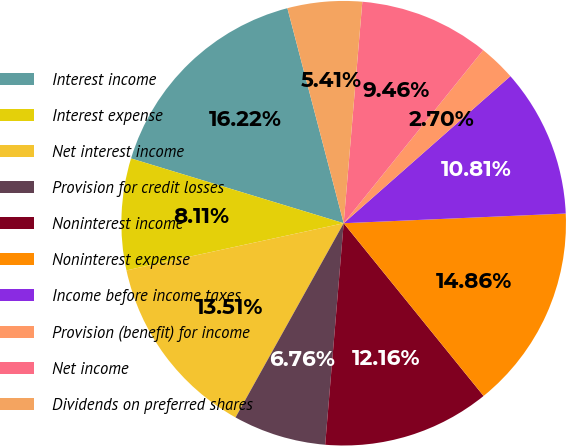Convert chart to OTSL. <chart><loc_0><loc_0><loc_500><loc_500><pie_chart><fcel>Interest income<fcel>Interest expense<fcel>Net interest income<fcel>Provision for credit losses<fcel>Noninterest income<fcel>Noninterest expense<fcel>Income before income taxes<fcel>Provision (benefit) for income<fcel>Net income<fcel>Dividends on preferred shares<nl><fcel>16.22%<fcel>8.11%<fcel>13.51%<fcel>6.76%<fcel>12.16%<fcel>14.86%<fcel>10.81%<fcel>2.7%<fcel>9.46%<fcel>5.41%<nl></chart> 